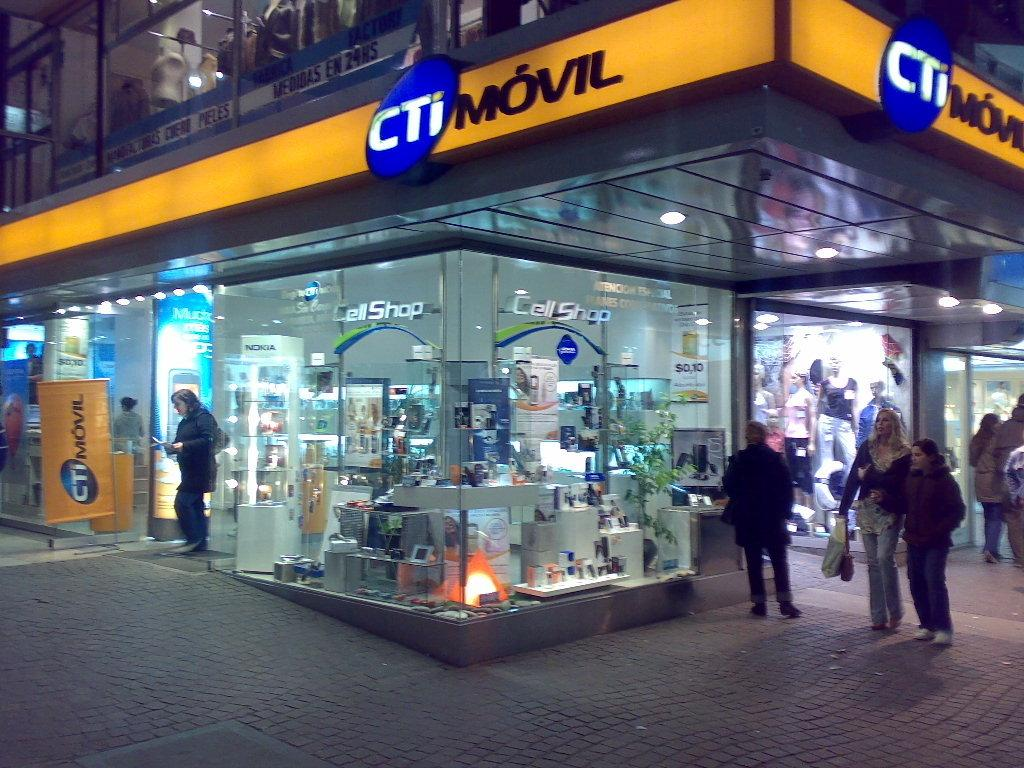What type of business is shown in the image? There is a cell shop in the image. Are there any people present in the image? Yes, there are people in the image. What time is displayed on the clock in the image? There is no clock present in the image, so we cannot determine the time. What type of gardening tool can be seen in the image? There is no gardening tool, such as a spade, present in the image. 